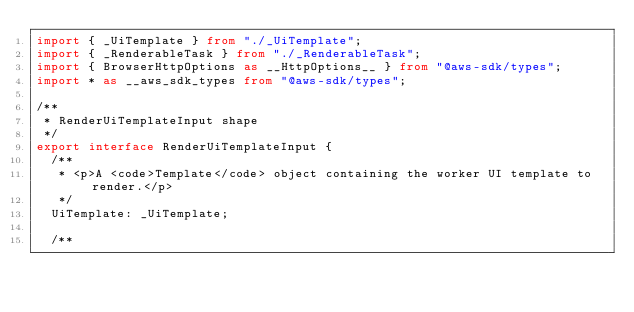<code> <loc_0><loc_0><loc_500><loc_500><_TypeScript_>import { _UiTemplate } from "./_UiTemplate";
import { _RenderableTask } from "./_RenderableTask";
import { BrowserHttpOptions as __HttpOptions__ } from "@aws-sdk/types";
import * as __aws_sdk_types from "@aws-sdk/types";

/**
 * RenderUiTemplateInput shape
 */
export interface RenderUiTemplateInput {
  /**
   * <p>A <code>Template</code> object containing the worker UI template to render.</p>
   */
  UiTemplate: _UiTemplate;

  /**</code> 